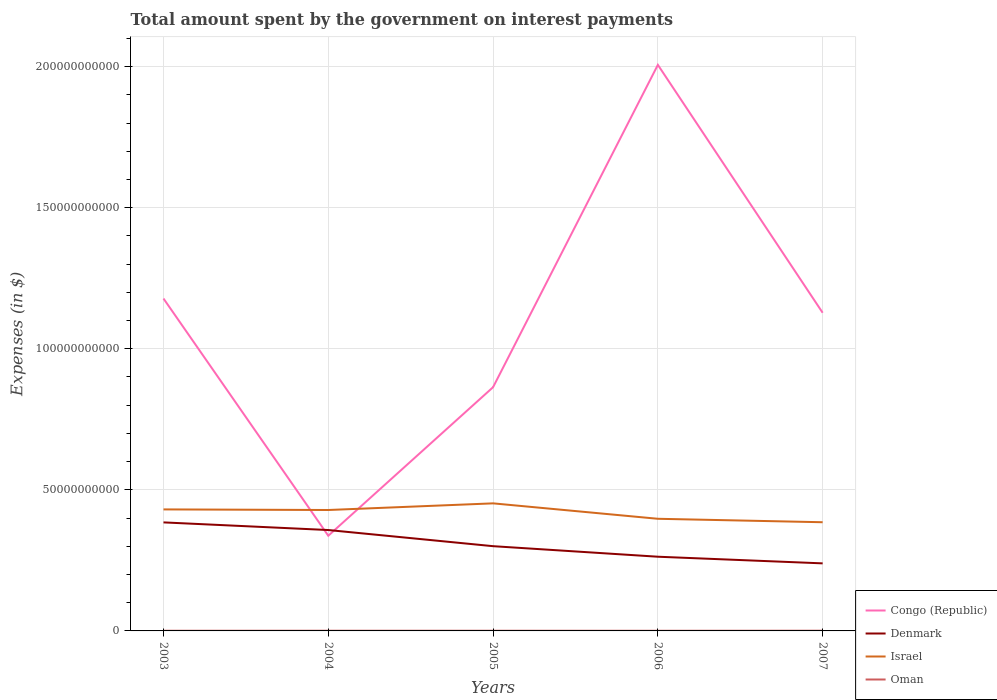Across all years, what is the maximum amount spent on interest payments by the government in Israel?
Give a very brief answer. 3.85e+1. What is the total amount spent on interest payments by the government in Denmark in the graph?
Keep it short and to the point. 6.09e+09. What is the difference between the highest and the second highest amount spent on interest payments by the government in Congo (Republic)?
Provide a succinct answer. 1.67e+11. What is the difference between the highest and the lowest amount spent on interest payments by the government in Congo (Republic)?
Your response must be concise. 3. Is the amount spent on interest payments by the government in Denmark strictly greater than the amount spent on interest payments by the government in Oman over the years?
Offer a terse response. No. How many years are there in the graph?
Offer a very short reply. 5. Are the values on the major ticks of Y-axis written in scientific E-notation?
Offer a very short reply. No. How many legend labels are there?
Offer a terse response. 4. What is the title of the graph?
Make the answer very short. Total amount spent by the government on interest payments. What is the label or title of the Y-axis?
Provide a succinct answer. Expenses (in $). What is the Expenses (in $) of Congo (Republic) in 2003?
Keep it short and to the point. 1.18e+11. What is the Expenses (in $) of Denmark in 2003?
Keep it short and to the point. 3.85e+1. What is the Expenses (in $) in Israel in 2003?
Make the answer very short. 4.31e+1. What is the Expenses (in $) in Oman in 2003?
Your answer should be compact. 5.99e+07. What is the Expenses (in $) in Congo (Republic) in 2004?
Offer a terse response. 3.37e+1. What is the Expenses (in $) of Denmark in 2004?
Provide a succinct answer. 3.58e+1. What is the Expenses (in $) in Israel in 2004?
Keep it short and to the point. 4.29e+1. What is the Expenses (in $) of Oman in 2004?
Your response must be concise. 7.44e+07. What is the Expenses (in $) of Congo (Republic) in 2005?
Provide a short and direct response. 8.64e+1. What is the Expenses (in $) in Denmark in 2005?
Your response must be concise. 3.00e+1. What is the Expenses (in $) in Israel in 2005?
Ensure brevity in your answer.  4.52e+1. What is the Expenses (in $) of Oman in 2005?
Your answer should be compact. 6.68e+07. What is the Expenses (in $) of Congo (Republic) in 2006?
Keep it short and to the point. 2.01e+11. What is the Expenses (in $) in Denmark in 2006?
Ensure brevity in your answer.  2.63e+1. What is the Expenses (in $) of Israel in 2006?
Your answer should be compact. 3.97e+1. What is the Expenses (in $) of Oman in 2006?
Your answer should be compact. 5.56e+07. What is the Expenses (in $) in Congo (Republic) in 2007?
Offer a very short reply. 1.13e+11. What is the Expenses (in $) of Denmark in 2007?
Provide a short and direct response. 2.39e+1. What is the Expenses (in $) of Israel in 2007?
Provide a succinct answer. 3.85e+1. What is the Expenses (in $) of Oman in 2007?
Provide a short and direct response. 7.77e+07. Across all years, what is the maximum Expenses (in $) in Congo (Republic)?
Offer a terse response. 2.01e+11. Across all years, what is the maximum Expenses (in $) in Denmark?
Your answer should be very brief. 3.85e+1. Across all years, what is the maximum Expenses (in $) of Israel?
Make the answer very short. 4.52e+1. Across all years, what is the maximum Expenses (in $) of Oman?
Offer a terse response. 7.77e+07. Across all years, what is the minimum Expenses (in $) of Congo (Republic)?
Your response must be concise. 3.37e+1. Across all years, what is the minimum Expenses (in $) in Denmark?
Your response must be concise. 2.39e+1. Across all years, what is the minimum Expenses (in $) of Israel?
Give a very brief answer. 3.85e+1. Across all years, what is the minimum Expenses (in $) in Oman?
Provide a succinct answer. 5.56e+07. What is the total Expenses (in $) of Congo (Republic) in the graph?
Your answer should be compact. 5.51e+11. What is the total Expenses (in $) in Denmark in the graph?
Make the answer very short. 1.55e+11. What is the total Expenses (in $) of Israel in the graph?
Your response must be concise. 2.09e+11. What is the total Expenses (in $) in Oman in the graph?
Make the answer very short. 3.34e+08. What is the difference between the Expenses (in $) in Congo (Republic) in 2003 and that in 2004?
Offer a very short reply. 8.41e+1. What is the difference between the Expenses (in $) of Denmark in 2003 and that in 2004?
Offer a terse response. 2.71e+09. What is the difference between the Expenses (in $) in Israel in 2003 and that in 2004?
Make the answer very short. 2.10e+08. What is the difference between the Expenses (in $) in Oman in 2003 and that in 2004?
Ensure brevity in your answer.  -1.45e+07. What is the difference between the Expenses (in $) of Congo (Republic) in 2003 and that in 2005?
Your answer should be very brief. 3.14e+1. What is the difference between the Expenses (in $) in Denmark in 2003 and that in 2005?
Keep it short and to the point. 8.43e+09. What is the difference between the Expenses (in $) in Israel in 2003 and that in 2005?
Ensure brevity in your answer.  -2.15e+09. What is the difference between the Expenses (in $) in Oman in 2003 and that in 2005?
Offer a terse response. -6.90e+06. What is the difference between the Expenses (in $) of Congo (Republic) in 2003 and that in 2006?
Ensure brevity in your answer.  -8.28e+1. What is the difference between the Expenses (in $) of Denmark in 2003 and that in 2006?
Offer a very short reply. 1.22e+1. What is the difference between the Expenses (in $) of Israel in 2003 and that in 2006?
Ensure brevity in your answer.  3.32e+09. What is the difference between the Expenses (in $) in Oman in 2003 and that in 2006?
Provide a succinct answer. 4.30e+06. What is the difference between the Expenses (in $) of Congo (Republic) in 2003 and that in 2007?
Your answer should be compact. 5.04e+09. What is the difference between the Expenses (in $) in Denmark in 2003 and that in 2007?
Provide a short and direct response. 1.45e+1. What is the difference between the Expenses (in $) in Israel in 2003 and that in 2007?
Offer a terse response. 4.55e+09. What is the difference between the Expenses (in $) in Oman in 2003 and that in 2007?
Give a very brief answer. -1.78e+07. What is the difference between the Expenses (in $) in Congo (Republic) in 2004 and that in 2005?
Provide a succinct answer. -5.27e+1. What is the difference between the Expenses (in $) of Denmark in 2004 and that in 2005?
Your response must be concise. 5.72e+09. What is the difference between the Expenses (in $) of Israel in 2004 and that in 2005?
Keep it short and to the point. -2.36e+09. What is the difference between the Expenses (in $) of Oman in 2004 and that in 2005?
Keep it short and to the point. 7.60e+06. What is the difference between the Expenses (in $) of Congo (Republic) in 2004 and that in 2006?
Offer a terse response. -1.67e+11. What is the difference between the Expenses (in $) in Denmark in 2004 and that in 2006?
Your answer should be compact. 9.46e+09. What is the difference between the Expenses (in $) in Israel in 2004 and that in 2006?
Offer a terse response. 3.11e+09. What is the difference between the Expenses (in $) in Oman in 2004 and that in 2006?
Keep it short and to the point. 1.88e+07. What is the difference between the Expenses (in $) in Congo (Republic) in 2004 and that in 2007?
Your answer should be very brief. -7.90e+1. What is the difference between the Expenses (in $) in Denmark in 2004 and that in 2007?
Your response must be concise. 1.18e+1. What is the difference between the Expenses (in $) in Israel in 2004 and that in 2007?
Your response must be concise. 4.34e+09. What is the difference between the Expenses (in $) of Oman in 2004 and that in 2007?
Provide a short and direct response. -3.30e+06. What is the difference between the Expenses (in $) of Congo (Republic) in 2005 and that in 2006?
Provide a succinct answer. -1.14e+11. What is the difference between the Expenses (in $) of Denmark in 2005 and that in 2006?
Offer a terse response. 3.73e+09. What is the difference between the Expenses (in $) of Israel in 2005 and that in 2006?
Your response must be concise. 5.47e+09. What is the difference between the Expenses (in $) of Oman in 2005 and that in 2006?
Provide a short and direct response. 1.12e+07. What is the difference between the Expenses (in $) of Congo (Republic) in 2005 and that in 2007?
Your answer should be compact. -2.64e+1. What is the difference between the Expenses (in $) in Denmark in 2005 and that in 2007?
Offer a very short reply. 6.09e+09. What is the difference between the Expenses (in $) of Israel in 2005 and that in 2007?
Your answer should be compact. 6.69e+09. What is the difference between the Expenses (in $) in Oman in 2005 and that in 2007?
Offer a terse response. -1.09e+07. What is the difference between the Expenses (in $) in Congo (Republic) in 2006 and that in 2007?
Ensure brevity in your answer.  8.79e+1. What is the difference between the Expenses (in $) in Denmark in 2006 and that in 2007?
Offer a very short reply. 2.36e+09. What is the difference between the Expenses (in $) in Israel in 2006 and that in 2007?
Offer a very short reply. 1.23e+09. What is the difference between the Expenses (in $) in Oman in 2006 and that in 2007?
Ensure brevity in your answer.  -2.21e+07. What is the difference between the Expenses (in $) in Congo (Republic) in 2003 and the Expenses (in $) in Denmark in 2004?
Ensure brevity in your answer.  8.20e+1. What is the difference between the Expenses (in $) of Congo (Republic) in 2003 and the Expenses (in $) of Israel in 2004?
Your answer should be very brief. 7.49e+1. What is the difference between the Expenses (in $) of Congo (Republic) in 2003 and the Expenses (in $) of Oman in 2004?
Your response must be concise. 1.18e+11. What is the difference between the Expenses (in $) in Denmark in 2003 and the Expenses (in $) in Israel in 2004?
Provide a short and direct response. -4.39e+09. What is the difference between the Expenses (in $) of Denmark in 2003 and the Expenses (in $) of Oman in 2004?
Your answer should be very brief. 3.84e+1. What is the difference between the Expenses (in $) in Israel in 2003 and the Expenses (in $) in Oman in 2004?
Offer a very short reply. 4.30e+1. What is the difference between the Expenses (in $) in Congo (Republic) in 2003 and the Expenses (in $) in Denmark in 2005?
Provide a short and direct response. 8.78e+1. What is the difference between the Expenses (in $) in Congo (Republic) in 2003 and the Expenses (in $) in Israel in 2005?
Offer a very short reply. 7.26e+1. What is the difference between the Expenses (in $) in Congo (Republic) in 2003 and the Expenses (in $) in Oman in 2005?
Keep it short and to the point. 1.18e+11. What is the difference between the Expenses (in $) in Denmark in 2003 and the Expenses (in $) in Israel in 2005?
Give a very brief answer. -6.75e+09. What is the difference between the Expenses (in $) in Denmark in 2003 and the Expenses (in $) in Oman in 2005?
Provide a short and direct response. 3.84e+1. What is the difference between the Expenses (in $) in Israel in 2003 and the Expenses (in $) in Oman in 2005?
Provide a succinct answer. 4.30e+1. What is the difference between the Expenses (in $) of Congo (Republic) in 2003 and the Expenses (in $) of Denmark in 2006?
Provide a short and direct response. 9.15e+1. What is the difference between the Expenses (in $) in Congo (Republic) in 2003 and the Expenses (in $) in Israel in 2006?
Offer a terse response. 7.81e+1. What is the difference between the Expenses (in $) of Congo (Republic) in 2003 and the Expenses (in $) of Oman in 2006?
Give a very brief answer. 1.18e+11. What is the difference between the Expenses (in $) of Denmark in 2003 and the Expenses (in $) of Israel in 2006?
Your answer should be compact. -1.28e+09. What is the difference between the Expenses (in $) in Denmark in 2003 and the Expenses (in $) in Oman in 2006?
Offer a very short reply. 3.84e+1. What is the difference between the Expenses (in $) of Israel in 2003 and the Expenses (in $) of Oman in 2006?
Make the answer very short. 4.30e+1. What is the difference between the Expenses (in $) in Congo (Republic) in 2003 and the Expenses (in $) in Denmark in 2007?
Provide a short and direct response. 9.39e+1. What is the difference between the Expenses (in $) of Congo (Republic) in 2003 and the Expenses (in $) of Israel in 2007?
Offer a very short reply. 7.93e+1. What is the difference between the Expenses (in $) of Congo (Republic) in 2003 and the Expenses (in $) of Oman in 2007?
Make the answer very short. 1.18e+11. What is the difference between the Expenses (in $) of Denmark in 2003 and the Expenses (in $) of Israel in 2007?
Your answer should be very brief. -5.19e+07. What is the difference between the Expenses (in $) in Denmark in 2003 and the Expenses (in $) in Oman in 2007?
Provide a short and direct response. 3.84e+1. What is the difference between the Expenses (in $) in Israel in 2003 and the Expenses (in $) in Oman in 2007?
Your response must be concise. 4.30e+1. What is the difference between the Expenses (in $) of Congo (Republic) in 2004 and the Expenses (in $) of Denmark in 2005?
Keep it short and to the point. 3.70e+09. What is the difference between the Expenses (in $) of Congo (Republic) in 2004 and the Expenses (in $) of Israel in 2005?
Provide a short and direct response. -1.15e+1. What is the difference between the Expenses (in $) in Congo (Republic) in 2004 and the Expenses (in $) in Oman in 2005?
Ensure brevity in your answer.  3.37e+1. What is the difference between the Expenses (in $) of Denmark in 2004 and the Expenses (in $) of Israel in 2005?
Your answer should be compact. -9.45e+09. What is the difference between the Expenses (in $) of Denmark in 2004 and the Expenses (in $) of Oman in 2005?
Ensure brevity in your answer.  3.57e+1. What is the difference between the Expenses (in $) in Israel in 2004 and the Expenses (in $) in Oman in 2005?
Your answer should be compact. 4.28e+1. What is the difference between the Expenses (in $) of Congo (Republic) in 2004 and the Expenses (in $) of Denmark in 2006?
Ensure brevity in your answer.  7.43e+09. What is the difference between the Expenses (in $) in Congo (Republic) in 2004 and the Expenses (in $) in Israel in 2006?
Give a very brief answer. -6.01e+09. What is the difference between the Expenses (in $) of Congo (Republic) in 2004 and the Expenses (in $) of Oman in 2006?
Ensure brevity in your answer.  3.37e+1. What is the difference between the Expenses (in $) in Denmark in 2004 and the Expenses (in $) in Israel in 2006?
Offer a terse response. -3.99e+09. What is the difference between the Expenses (in $) of Denmark in 2004 and the Expenses (in $) of Oman in 2006?
Ensure brevity in your answer.  3.57e+1. What is the difference between the Expenses (in $) in Israel in 2004 and the Expenses (in $) in Oman in 2006?
Offer a terse response. 4.28e+1. What is the difference between the Expenses (in $) of Congo (Republic) in 2004 and the Expenses (in $) of Denmark in 2007?
Offer a very short reply. 9.79e+09. What is the difference between the Expenses (in $) of Congo (Republic) in 2004 and the Expenses (in $) of Israel in 2007?
Keep it short and to the point. -4.79e+09. What is the difference between the Expenses (in $) in Congo (Republic) in 2004 and the Expenses (in $) in Oman in 2007?
Ensure brevity in your answer.  3.37e+1. What is the difference between the Expenses (in $) in Denmark in 2004 and the Expenses (in $) in Israel in 2007?
Make the answer very short. -2.76e+09. What is the difference between the Expenses (in $) in Denmark in 2004 and the Expenses (in $) in Oman in 2007?
Ensure brevity in your answer.  3.57e+1. What is the difference between the Expenses (in $) in Israel in 2004 and the Expenses (in $) in Oman in 2007?
Provide a short and direct response. 4.28e+1. What is the difference between the Expenses (in $) of Congo (Republic) in 2005 and the Expenses (in $) of Denmark in 2006?
Your answer should be very brief. 6.01e+1. What is the difference between the Expenses (in $) in Congo (Republic) in 2005 and the Expenses (in $) in Israel in 2006?
Make the answer very short. 4.66e+1. What is the difference between the Expenses (in $) of Congo (Republic) in 2005 and the Expenses (in $) of Oman in 2006?
Keep it short and to the point. 8.63e+1. What is the difference between the Expenses (in $) of Denmark in 2005 and the Expenses (in $) of Israel in 2006?
Offer a terse response. -9.71e+09. What is the difference between the Expenses (in $) in Denmark in 2005 and the Expenses (in $) in Oman in 2006?
Ensure brevity in your answer.  3.00e+1. What is the difference between the Expenses (in $) in Israel in 2005 and the Expenses (in $) in Oman in 2006?
Offer a very short reply. 4.52e+1. What is the difference between the Expenses (in $) in Congo (Republic) in 2005 and the Expenses (in $) in Denmark in 2007?
Your response must be concise. 6.24e+1. What is the difference between the Expenses (in $) of Congo (Republic) in 2005 and the Expenses (in $) of Israel in 2007?
Give a very brief answer. 4.79e+1. What is the difference between the Expenses (in $) of Congo (Republic) in 2005 and the Expenses (in $) of Oman in 2007?
Offer a very short reply. 8.63e+1. What is the difference between the Expenses (in $) of Denmark in 2005 and the Expenses (in $) of Israel in 2007?
Give a very brief answer. -8.48e+09. What is the difference between the Expenses (in $) of Denmark in 2005 and the Expenses (in $) of Oman in 2007?
Provide a succinct answer. 3.00e+1. What is the difference between the Expenses (in $) in Israel in 2005 and the Expenses (in $) in Oman in 2007?
Provide a succinct answer. 4.51e+1. What is the difference between the Expenses (in $) in Congo (Republic) in 2006 and the Expenses (in $) in Denmark in 2007?
Give a very brief answer. 1.77e+11. What is the difference between the Expenses (in $) in Congo (Republic) in 2006 and the Expenses (in $) in Israel in 2007?
Give a very brief answer. 1.62e+11. What is the difference between the Expenses (in $) in Congo (Republic) in 2006 and the Expenses (in $) in Oman in 2007?
Your answer should be compact. 2.01e+11. What is the difference between the Expenses (in $) of Denmark in 2006 and the Expenses (in $) of Israel in 2007?
Your answer should be compact. -1.22e+1. What is the difference between the Expenses (in $) of Denmark in 2006 and the Expenses (in $) of Oman in 2007?
Offer a very short reply. 2.62e+1. What is the difference between the Expenses (in $) of Israel in 2006 and the Expenses (in $) of Oman in 2007?
Make the answer very short. 3.97e+1. What is the average Expenses (in $) in Congo (Republic) per year?
Provide a short and direct response. 1.10e+11. What is the average Expenses (in $) in Denmark per year?
Provide a succinct answer. 3.09e+1. What is the average Expenses (in $) in Israel per year?
Provide a short and direct response. 4.19e+1. What is the average Expenses (in $) in Oman per year?
Your answer should be compact. 6.69e+07. In the year 2003, what is the difference between the Expenses (in $) of Congo (Republic) and Expenses (in $) of Denmark?
Give a very brief answer. 7.93e+1. In the year 2003, what is the difference between the Expenses (in $) of Congo (Republic) and Expenses (in $) of Israel?
Provide a short and direct response. 7.47e+1. In the year 2003, what is the difference between the Expenses (in $) of Congo (Republic) and Expenses (in $) of Oman?
Make the answer very short. 1.18e+11. In the year 2003, what is the difference between the Expenses (in $) in Denmark and Expenses (in $) in Israel?
Provide a short and direct response. -4.60e+09. In the year 2003, what is the difference between the Expenses (in $) of Denmark and Expenses (in $) of Oman?
Keep it short and to the point. 3.84e+1. In the year 2003, what is the difference between the Expenses (in $) in Israel and Expenses (in $) in Oman?
Ensure brevity in your answer.  4.30e+1. In the year 2004, what is the difference between the Expenses (in $) in Congo (Republic) and Expenses (in $) in Denmark?
Make the answer very short. -2.03e+09. In the year 2004, what is the difference between the Expenses (in $) of Congo (Republic) and Expenses (in $) of Israel?
Give a very brief answer. -9.12e+09. In the year 2004, what is the difference between the Expenses (in $) of Congo (Republic) and Expenses (in $) of Oman?
Your answer should be very brief. 3.37e+1. In the year 2004, what is the difference between the Expenses (in $) in Denmark and Expenses (in $) in Israel?
Give a very brief answer. -7.10e+09. In the year 2004, what is the difference between the Expenses (in $) in Denmark and Expenses (in $) in Oman?
Keep it short and to the point. 3.57e+1. In the year 2004, what is the difference between the Expenses (in $) of Israel and Expenses (in $) of Oman?
Ensure brevity in your answer.  4.28e+1. In the year 2005, what is the difference between the Expenses (in $) of Congo (Republic) and Expenses (in $) of Denmark?
Ensure brevity in your answer.  5.64e+1. In the year 2005, what is the difference between the Expenses (in $) in Congo (Republic) and Expenses (in $) in Israel?
Provide a short and direct response. 4.12e+1. In the year 2005, what is the difference between the Expenses (in $) of Congo (Republic) and Expenses (in $) of Oman?
Provide a short and direct response. 8.63e+1. In the year 2005, what is the difference between the Expenses (in $) in Denmark and Expenses (in $) in Israel?
Provide a short and direct response. -1.52e+1. In the year 2005, what is the difference between the Expenses (in $) in Denmark and Expenses (in $) in Oman?
Your response must be concise. 3.00e+1. In the year 2005, what is the difference between the Expenses (in $) in Israel and Expenses (in $) in Oman?
Your answer should be compact. 4.51e+1. In the year 2006, what is the difference between the Expenses (in $) in Congo (Republic) and Expenses (in $) in Denmark?
Give a very brief answer. 1.74e+11. In the year 2006, what is the difference between the Expenses (in $) in Congo (Republic) and Expenses (in $) in Israel?
Offer a terse response. 1.61e+11. In the year 2006, what is the difference between the Expenses (in $) of Congo (Republic) and Expenses (in $) of Oman?
Offer a terse response. 2.01e+11. In the year 2006, what is the difference between the Expenses (in $) of Denmark and Expenses (in $) of Israel?
Ensure brevity in your answer.  -1.34e+1. In the year 2006, what is the difference between the Expenses (in $) of Denmark and Expenses (in $) of Oman?
Your answer should be compact. 2.62e+1. In the year 2006, what is the difference between the Expenses (in $) of Israel and Expenses (in $) of Oman?
Your answer should be very brief. 3.97e+1. In the year 2007, what is the difference between the Expenses (in $) of Congo (Republic) and Expenses (in $) of Denmark?
Offer a terse response. 8.88e+1. In the year 2007, what is the difference between the Expenses (in $) in Congo (Republic) and Expenses (in $) in Israel?
Your answer should be compact. 7.42e+1. In the year 2007, what is the difference between the Expenses (in $) in Congo (Republic) and Expenses (in $) in Oman?
Make the answer very short. 1.13e+11. In the year 2007, what is the difference between the Expenses (in $) in Denmark and Expenses (in $) in Israel?
Your response must be concise. -1.46e+1. In the year 2007, what is the difference between the Expenses (in $) in Denmark and Expenses (in $) in Oman?
Provide a succinct answer. 2.39e+1. In the year 2007, what is the difference between the Expenses (in $) in Israel and Expenses (in $) in Oman?
Offer a terse response. 3.84e+1. What is the ratio of the Expenses (in $) of Congo (Republic) in 2003 to that in 2004?
Keep it short and to the point. 3.49. What is the ratio of the Expenses (in $) of Denmark in 2003 to that in 2004?
Your response must be concise. 1.08. What is the ratio of the Expenses (in $) in Israel in 2003 to that in 2004?
Provide a succinct answer. 1. What is the ratio of the Expenses (in $) of Oman in 2003 to that in 2004?
Keep it short and to the point. 0.81. What is the ratio of the Expenses (in $) in Congo (Republic) in 2003 to that in 2005?
Give a very brief answer. 1.36. What is the ratio of the Expenses (in $) in Denmark in 2003 to that in 2005?
Provide a short and direct response. 1.28. What is the ratio of the Expenses (in $) of Israel in 2003 to that in 2005?
Make the answer very short. 0.95. What is the ratio of the Expenses (in $) in Oman in 2003 to that in 2005?
Offer a terse response. 0.9. What is the ratio of the Expenses (in $) of Congo (Republic) in 2003 to that in 2006?
Offer a terse response. 0.59. What is the ratio of the Expenses (in $) of Denmark in 2003 to that in 2006?
Provide a short and direct response. 1.46. What is the ratio of the Expenses (in $) in Israel in 2003 to that in 2006?
Provide a succinct answer. 1.08. What is the ratio of the Expenses (in $) of Oman in 2003 to that in 2006?
Provide a short and direct response. 1.08. What is the ratio of the Expenses (in $) of Congo (Republic) in 2003 to that in 2007?
Provide a succinct answer. 1.04. What is the ratio of the Expenses (in $) of Denmark in 2003 to that in 2007?
Your answer should be very brief. 1.61. What is the ratio of the Expenses (in $) in Israel in 2003 to that in 2007?
Provide a short and direct response. 1.12. What is the ratio of the Expenses (in $) in Oman in 2003 to that in 2007?
Your response must be concise. 0.77. What is the ratio of the Expenses (in $) in Congo (Republic) in 2004 to that in 2005?
Provide a succinct answer. 0.39. What is the ratio of the Expenses (in $) of Denmark in 2004 to that in 2005?
Make the answer very short. 1.19. What is the ratio of the Expenses (in $) in Israel in 2004 to that in 2005?
Offer a very short reply. 0.95. What is the ratio of the Expenses (in $) in Oman in 2004 to that in 2005?
Keep it short and to the point. 1.11. What is the ratio of the Expenses (in $) in Congo (Republic) in 2004 to that in 2006?
Ensure brevity in your answer.  0.17. What is the ratio of the Expenses (in $) of Denmark in 2004 to that in 2006?
Make the answer very short. 1.36. What is the ratio of the Expenses (in $) of Israel in 2004 to that in 2006?
Your answer should be compact. 1.08. What is the ratio of the Expenses (in $) in Oman in 2004 to that in 2006?
Ensure brevity in your answer.  1.34. What is the ratio of the Expenses (in $) in Congo (Republic) in 2004 to that in 2007?
Ensure brevity in your answer.  0.3. What is the ratio of the Expenses (in $) of Denmark in 2004 to that in 2007?
Ensure brevity in your answer.  1.49. What is the ratio of the Expenses (in $) of Israel in 2004 to that in 2007?
Your answer should be very brief. 1.11. What is the ratio of the Expenses (in $) in Oman in 2004 to that in 2007?
Your answer should be compact. 0.96. What is the ratio of the Expenses (in $) of Congo (Republic) in 2005 to that in 2006?
Ensure brevity in your answer.  0.43. What is the ratio of the Expenses (in $) in Denmark in 2005 to that in 2006?
Give a very brief answer. 1.14. What is the ratio of the Expenses (in $) of Israel in 2005 to that in 2006?
Provide a short and direct response. 1.14. What is the ratio of the Expenses (in $) in Oman in 2005 to that in 2006?
Give a very brief answer. 1.2. What is the ratio of the Expenses (in $) in Congo (Republic) in 2005 to that in 2007?
Provide a succinct answer. 0.77. What is the ratio of the Expenses (in $) of Denmark in 2005 to that in 2007?
Ensure brevity in your answer.  1.25. What is the ratio of the Expenses (in $) in Israel in 2005 to that in 2007?
Your response must be concise. 1.17. What is the ratio of the Expenses (in $) in Oman in 2005 to that in 2007?
Give a very brief answer. 0.86. What is the ratio of the Expenses (in $) of Congo (Republic) in 2006 to that in 2007?
Offer a terse response. 1.78. What is the ratio of the Expenses (in $) of Denmark in 2006 to that in 2007?
Keep it short and to the point. 1.1. What is the ratio of the Expenses (in $) of Israel in 2006 to that in 2007?
Keep it short and to the point. 1.03. What is the ratio of the Expenses (in $) in Oman in 2006 to that in 2007?
Provide a short and direct response. 0.72. What is the difference between the highest and the second highest Expenses (in $) in Congo (Republic)?
Provide a short and direct response. 8.28e+1. What is the difference between the highest and the second highest Expenses (in $) in Denmark?
Your answer should be very brief. 2.71e+09. What is the difference between the highest and the second highest Expenses (in $) of Israel?
Your answer should be compact. 2.15e+09. What is the difference between the highest and the second highest Expenses (in $) of Oman?
Your response must be concise. 3.30e+06. What is the difference between the highest and the lowest Expenses (in $) in Congo (Republic)?
Offer a very short reply. 1.67e+11. What is the difference between the highest and the lowest Expenses (in $) of Denmark?
Offer a terse response. 1.45e+1. What is the difference between the highest and the lowest Expenses (in $) in Israel?
Offer a terse response. 6.69e+09. What is the difference between the highest and the lowest Expenses (in $) of Oman?
Your answer should be very brief. 2.21e+07. 